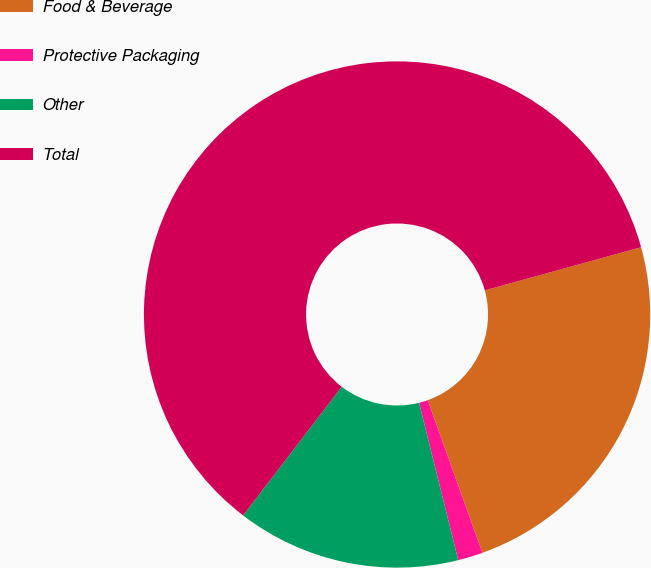Convert chart. <chart><loc_0><loc_0><loc_500><loc_500><pie_chart><fcel>Food & Beverage<fcel>Protective Packaging<fcel>Other<fcel>Total<nl><fcel>23.81%<fcel>1.59%<fcel>14.29%<fcel>60.32%<nl></chart> 